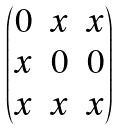<formula> <loc_0><loc_0><loc_500><loc_500>\begin{pmatrix} 0 & x & x \\ x & 0 & 0 \\ x & x & x \\ \end{pmatrix}</formula> 